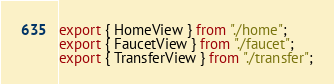<code> <loc_0><loc_0><loc_500><loc_500><_TypeScript_>export { HomeView } from "./home";
export { FaucetView } from "./faucet";
export { TransferView } from "./transfer";
</code> 